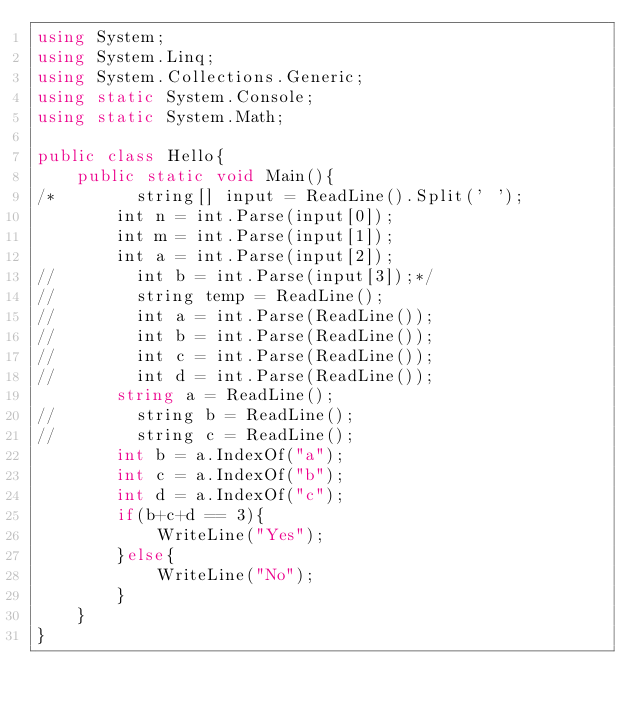<code> <loc_0><loc_0><loc_500><loc_500><_C#_>using System;
using System.Linq;
using System.Collections.Generic;
using static System.Console;
using static System.Math;
 
public class Hello{
    public static void Main(){
/*        string[] input = ReadLine().Split(' ');
        int n = int.Parse(input[0]);
        int m = int.Parse(input[1]);
        int a = int.Parse(input[2]);
//        int b = int.Parse(input[3]);*/
//        string temp = ReadLine();
//        int a = int.Parse(ReadLine());
//        int b = int.Parse(ReadLine());
//        int c = int.Parse(ReadLine());
//        int d = int.Parse(ReadLine());
        string a = ReadLine();
//        string b = ReadLine();
//        string c = ReadLine();
        int b = a.IndexOf("a");
        int c = a.IndexOf("b");
        int d = a.IndexOf("c");
        if(b+c+d == 3){
            WriteLine("Yes");
        }else{
            WriteLine("No");
        }
    }
}</code> 